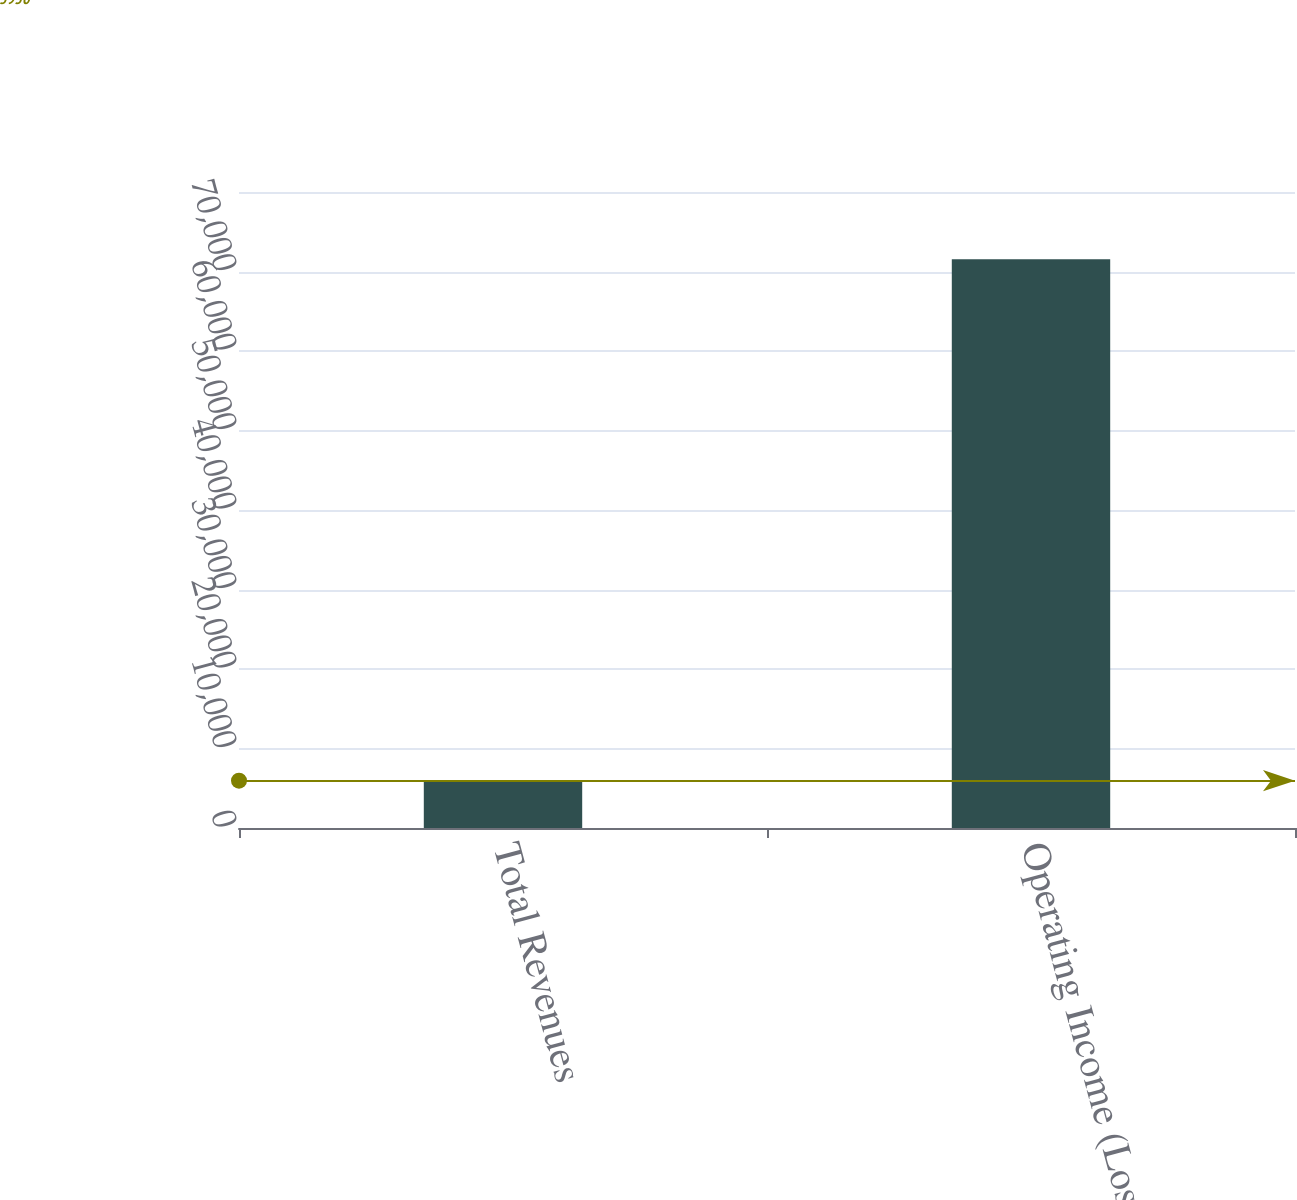<chart> <loc_0><loc_0><loc_500><loc_500><bar_chart><fcel>Total Revenues<fcel>Operating Income (Loss)<nl><fcel>5950<fcel>71556<nl></chart> 